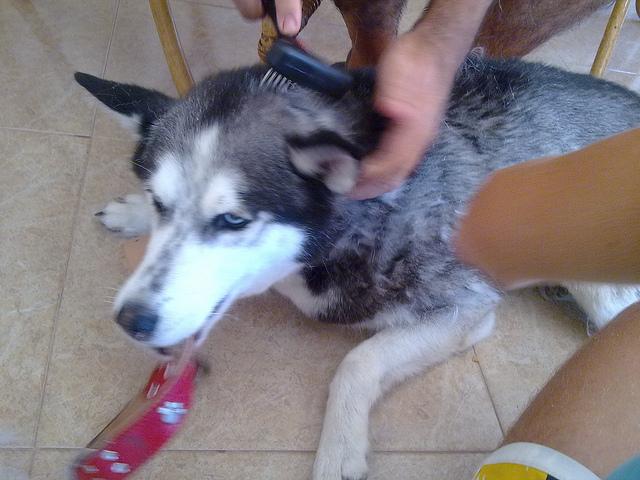Does the dog like being brushed?
Keep it brief. Yes. What breed of dog is in the photo?
Be succinct. Husky. What breed of dog is that?
Keep it brief. Husky. Is the dog being groomed?
Answer briefly. Yes. What kind of dog is this?
Give a very brief answer. Husky. 